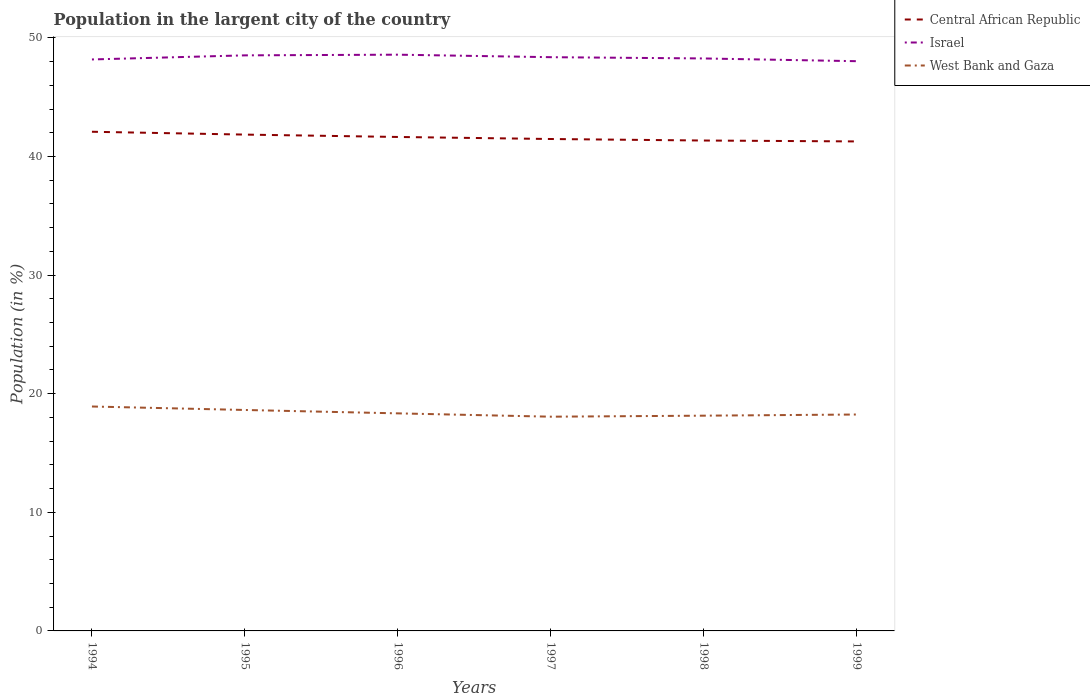Is the number of lines equal to the number of legend labels?
Ensure brevity in your answer.  Yes. Across all years, what is the maximum percentage of population in the largent city in Central African Republic?
Provide a succinct answer. 41.27. What is the total percentage of population in the largent city in West Bank and Gaza in the graph?
Offer a very short reply. 0.86. What is the difference between the highest and the second highest percentage of population in the largent city in West Bank and Gaza?
Provide a succinct answer. 0.86. Is the percentage of population in the largent city in Israel strictly greater than the percentage of population in the largent city in Central African Republic over the years?
Provide a succinct answer. No. What is the difference between two consecutive major ticks on the Y-axis?
Offer a very short reply. 10. Does the graph contain grids?
Make the answer very short. No. What is the title of the graph?
Ensure brevity in your answer.  Population in the largent city of the country. Does "Iraq" appear as one of the legend labels in the graph?
Ensure brevity in your answer.  No. What is the label or title of the X-axis?
Ensure brevity in your answer.  Years. What is the label or title of the Y-axis?
Your response must be concise. Population (in %). What is the Population (in %) of Central African Republic in 1994?
Your answer should be compact. 42.08. What is the Population (in %) in Israel in 1994?
Provide a short and direct response. 48.18. What is the Population (in %) of West Bank and Gaza in 1994?
Your answer should be very brief. 18.92. What is the Population (in %) in Central African Republic in 1995?
Give a very brief answer. 41.85. What is the Population (in %) in Israel in 1995?
Provide a short and direct response. 48.53. What is the Population (in %) in West Bank and Gaza in 1995?
Offer a terse response. 18.63. What is the Population (in %) in Central African Republic in 1996?
Make the answer very short. 41.65. What is the Population (in %) of Israel in 1996?
Your answer should be compact. 48.58. What is the Population (in %) of West Bank and Gaza in 1996?
Offer a terse response. 18.34. What is the Population (in %) of Central African Republic in 1997?
Provide a succinct answer. 41.47. What is the Population (in %) in Israel in 1997?
Your answer should be very brief. 48.37. What is the Population (in %) in West Bank and Gaza in 1997?
Give a very brief answer. 18.06. What is the Population (in %) of Central African Republic in 1998?
Offer a terse response. 41.35. What is the Population (in %) of Israel in 1998?
Your response must be concise. 48.26. What is the Population (in %) of West Bank and Gaza in 1998?
Provide a short and direct response. 18.15. What is the Population (in %) of Central African Republic in 1999?
Provide a succinct answer. 41.27. What is the Population (in %) in Israel in 1999?
Give a very brief answer. 48.03. What is the Population (in %) in West Bank and Gaza in 1999?
Ensure brevity in your answer.  18.25. Across all years, what is the maximum Population (in %) of Central African Republic?
Make the answer very short. 42.08. Across all years, what is the maximum Population (in %) of Israel?
Provide a short and direct response. 48.58. Across all years, what is the maximum Population (in %) in West Bank and Gaza?
Provide a succinct answer. 18.92. Across all years, what is the minimum Population (in %) of Central African Republic?
Your answer should be very brief. 41.27. Across all years, what is the minimum Population (in %) in Israel?
Give a very brief answer. 48.03. Across all years, what is the minimum Population (in %) of West Bank and Gaza?
Your answer should be compact. 18.06. What is the total Population (in %) of Central African Republic in the graph?
Your answer should be compact. 249.66. What is the total Population (in %) in Israel in the graph?
Provide a succinct answer. 289.96. What is the total Population (in %) in West Bank and Gaza in the graph?
Provide a succinct answer. 110.35. What is the difference between the Population (in %) of Central African Republic in 1994 and that in 1995?
Keep it short and to the point. 0.24. What is the difference between the Population (in %) of Israel in 1994 and that in 1995?
Your answer should be compact. -0.35. What is the difference between the Population (in %) in West Bank and Gaza in 1994 and that in 1995?
Your response must be concise. 0.29. What is the difference between the Population (in %) in Central African Republic in 1994 and that in 1996?
Give a very brief answer. 0.44. What is the difference between the Population (in %) in Israel in 1994 and that in 1996?
Provide a succinct answer. -0.4. What is the difference between the Population (in %) in West Bank and Gaza in 1994 and that in 1996?
Ensure brevity in your answer.  0.58. What is the difference between the Population (in %) of Central African Republic in 1994 and that in 1997?
Provide a succinct answer. 0.61. What is the difference between the Population (in %) of Israel in 1994 and that in 1997?
Give a very brief answer. -0.19. What is the difference between the Population (in %) of West Bank and Gaza in 1994 and that in 1997?
Your response must be concise. 0.86. What is the difference between the Population (in %) in Central African Republic in 1994 and that in 1998?
Your answer should be very brief. 0.74. What is the difference between the Population (in %) in Israel in 1994 and that in 1998?
Provide a succinct answer. -0.08. What is the difference between the Population (in %) of West Bank and Gaza in 1994 and that in 1998?
Make the answer very short. 0.77. What is the difference between the Population (in %) in Central African Republic in 1994 and that in 1999?
Provide a succinct answer. 0.82. What is the difference between the Population (in %) of Israel in 1994 and that in 1999?
Offer a very short reply. 0.15. What is the difference between the Population (in %) in West Bank and Gaza in 1994 and that in 1999?
Ensure brevity in your answer.  0.68. What is the difference between the Population (in %) in Central African Republic in 1995 and that in 1996?
Give a very brief answer. 0.2. What is the difference between the Population (in %) in Israel in 1995 and that in 1996?
Offer a very short reply. -0.06. What is the difference between the Population (in %) in West Bank and Gaza in 1995 and that in 1996?
Offer a very short reply. 0.29. What is the difference between the Population (in %) in Central African Republic in 1995 and that in 1997?
Offer a very short reply. 0.37. What is the difference between the Population (in %) in Israel in 1995 and that in 1997?
Provide a succinct answer. 0.15. What is the difference between the Population (in %) in West Bank and Gaza in 1995 and that in 1997?
Your answer should be very brief. 0.57. What is the difference between the Population (in %) of Israel in 1995 and that in 1998?
Ensure brevity in your answer.  0.26. What is the difference between the Population (in %) in West Bank and Gaza in 1995 and that in 1998?
Your answer should be compact. 0.48. What is the difference between the Population (in %) in Central African Republic in 1995 and that in 1999?
Your response must be concise. 0.58. What is the difference between the Population (in %) of Israel in 1995 and that in 1999?
Offer a terse response. 0.49. What is the difference between the Population (in %) in West Bank and Gaza in 1995 and that in 1999?
Offer a very short reply. 0.38. What is the difference between the Population (in %) of Central African Republic in 1996 and that in 1997?
Keep it short and to the point. 0.17. What is the difference between the Population (in %) in Israel in 1996 and that in 1997?
Provide a short and direct response. 0.21. What is the difference between the Population (in %) in West Bank and Gaza in 1996 and that in 1997?
Offer a very short reply. 0.28. What is the difference between the Population (in %) in Israel in 1996 and that in 1998?
Keep it short and to the point. 0.32. What is the difference between the Population (in %) in West Bank and Gaza in 1996 and that in 1998?
Your answer should be compact. 0.19. What is the difference between the Population (in %) in Central African Republic in 1996 and that in 1999?
Provide a short and direct response. 0.38. What is the difference between the Population (in %) in Israel in 1996 and that in 1999?
Your response must be concise. 0.55. What is the difference between the Population (in %) of West Bank and Gaza in 1996 and that in 1999?
Offer a very short reply. 0.1. What is the difference between the Population (in %) of Central African Republic in 1997 and that in 1998?
Make the answer very short. 0.13. What is the difference between the Population (in %) in Israel in 1997 and that in 1998?
Your response must be concise. 0.11. What is the difference between the Population (in %) of West Bank and Gaza in 1997 and that in 1998?
Provide a succinct answer. -0.09. What is the difference between the Population (in %) in Central African Republic in 1997 and that in 1999?
Your answer should be very brief. 0.2. What is the difference between the Population (in %) of Israel in 1997 and that in 1999?
Offer a very short reply. 0.34. What is the difference between the Population (in %) in West Bank and Gaza in 1997 and that in 1999?
Make the answer very short. -0.18. What is the difference between the Population (in %) of Central African Republic in 1998 and that in 1999?
Provide a succinct answer. 0.08. What is the difference between the Population (in %) of Israel in 1998 and that in 1999?
Offer a terse response. 0.23. What is the difference between the Population (in %) in West Bank and Gaza in 1998 and that in 1999?
Your answer should be very brief. -0.1. What is the difference between the Population (in %) of Central African Republic in 1994 and the Population (in %) of Israel in 1995?
Provide a short and direct response. -6.44. What is the difference between the Population (in %) of Central African Republic in 1994 and the Population (in %) of West Bank and Gaza in 1995?
Keep it short and to the point. 23.46. What is the difference between the Population (in %) in Israel in 1994 and the Population (in %) in West Bank and Gaza in 1995?
Your response must be concise. 29.55. What is the difference between the Population (in %) in Central African Republic in 1994 and the Population (in %) in Israel in 1996?
Make the answer very short. -6.5. What is the difference between the Population (in %) of Central African Republic in 1994 and the Population (in %) of West Bank and Gaza in 1996?
Your answer should be compact. 23.74. What is the difference between the Population (in %) of Israel in 1994 and the Population (in %) of West Bank and Gaza in 1996?
Provide a short and direct response. 29.84. What is the difference between the Population (in %) of Central African Republic in 1994 and the Population (in %) of Israel in 1997?
Provide a succinct answer. -6.29. What is the difference between the Population (in %) in Central African Republic in 1994 and the Population (in %) in West Bank and Gaza in 1997?
Ensure brevity in your answer.  24.02. What is the difference between the Population (in %) of Israel in 1994 and the Population (in %) of West Bank and Gaza in 1997?
Offer a very short reply. 30.12. What is the difference between the Population (in %) of Central African Republic in 1994 and the Population (in %) of Israel in 1998?
Your answer should be very brief. -6.18. What is the difference between the Population (in %) of Central African Republic in 1994 and the Population (in %) of West Bank and Gaza in 1998?
Provide a short and direct response. 23.94. What is the difference between the Population (in %) of Israel in 1994 and the Population (in %) of West Bank and Gaza in 1998?
Ensure brevity in your answer.  30.03. What is the difference between the Population (in %) of Central African Republic in 1994 and the Population (in %) of Israel in 1999?
Ensure brevity in your answer.  -5.95. What is the difference between the Population (in %) of Central African Republic in 1994 and the Population (in %) of West Bank and Gaza in 1999?
Your answer should be compact. 23.84. What is the difference between the Population (in %) of Israel in 1994 and the Population (in %) of West Bank and Gaza in 1999?
Make the answer very short. 29.93. What is the difference between the Population (in %) in Central African Republic in 1995 and the Population (in %) in Israel in 1996?
Provide a succinct answer. -6.74. What is the difference between the Population (in %) in Central African Republic in 1995 and the Population (in %) in West Bank and Gaza in 1996?
Your response must be concise. 23.5. What is the difference between the Population (in %) of Israel in 1995 and the Population (in %) of West Bank and Gaza in 1996?
Your response must be concise. 30.18. What is the difference between the Population (in %) in Central African Republic in 1995 and the Population (in %) in Israel in 1997?
Your answer should be compact. -6.53. What is the difference between the Population (in %) in Central African Republic in 1995 and the Population (in %) in West Bank and Gaza in 1997?
Make the answer very short. 23.78. What is the difference between the Population (in %) of Israel in 1995 and the Population (in %) of West Bank and Gaza in 1997?
Ensure brevity in your answer.  30.46. What is the difference between the Population (in %) in Central African Republic in 1995 and the Population (in %) in Israel in 1998?
Provide a succinct answer. -6.42. What is the difference between the Population (in %) of Central African Republic in 1995 and the Population (in %) of West Bank and Gaza in 1998?
Make the answer very short. 23.7. What is the difference between the Population (in %) in Israel in 1995 and the Population (in %) in West Bank and Gaza in 1998?
Provide a short and direct response. 30.38. What is the difference between the Population (in %) of Central African Republic in 1995 and the Population (in %) of Israel in 1999?
Make the answer very short. -6.19. What is the difference between the Population (in %) of Central African Republic in 1995 and the Population (in %) of West Bank and Gaza in 1999?
Offer a terse response. 23.6. What is the difference between the Population (in %) in Israel in 1995 and the Population (in %) in West Bank and Gaza in 1999?
Make the answer very short. 30.28. What is the difference between the Population (in %) in Central African Republic in 1996 and the Population (in %) in Israel in 1997?
Keep it short and to the point. -6.73. What is the difference between the Population (in %) of Central African Republic in 1996 and the Population (in %) of West Bank and Gaza in 1997?
Make the answer very short. 23.58. What is the difference between the Population (in %) in Israel in 1996 and the Population (in %) in West Bank and Gaza in 1997?
Offer a terse response. 30.52. What is the difference between the Population (in %) of Central African Republic in 1996 and the Population (in %) of Israel in 1998?
Offer a very short reply. -6.62. What is the difference between the Population (in %) in Central African Republic in 1996 and the Population (in %) in West Bank and Gaza in 1998?
Make the answer very short. 23.5. What is the difference between the Population (in %) in Israel in 1996 and the Population (in %) in West Bank and Gaza in 1998?
Keep it short and to the point. 30.44. What is the difference between the Population (in %) in Central African Republic in 1996 and the Population (in %) in Israel in 1999?
Your answer should be very brief. -6.39. What is the difference between the Population (in %) of Central African Republic in 1996 and the Population (in %) of West Bank and Gaza in 1999?
Provide a succinct answer. 23.4. What is the difference between the Population (in %) in Israel in 1996 and the Population (in %) in West Bank and Gaza in 1999?
Offer a very short reply. 30.34. What is the difference between the Population (in %) of Central African Republic in 1997 and the Population (in %) of Israel in 1998?
Your answer should be compact. -6.79. What is the difference between the Population (in %) in Central African Republic in 1997 and the Population (in %) in West Bank and Gaza in 1998?
Your response must be concise. 23.33. What is the difference between the Population (in %) in Israel in 1997 and the Population (in %) in West Bank and Gaza in 1998?
Your response must be concise. 30.22. What is the difference between the Population (in %) in Central African Republic in 1997 and the Population (in %) in Israel in 1999?
Your response must be concise. -6.56. What is the difference between the Population (in %) in Central African Republic in 1997 and the Population (in %) in West Bank and Gaza in 1999?
Ensure brevity in your answer.  23.23. What is the difference between the Population (in %) of Israel in 1997 and the Population (in %) of West Bank and Gaza in 1999?
Provide a short and direct response. 30.13. What is the difference between the Population (in %) of Central African Republic in 1998 and the Population (in %) of Israel in 1999?
Make the answer very short. -6.69. What is the difference between the Population (in %) of Central African Republic in 1998 and the Population (in %) of West Bank and Gaza in 1999?
Your answer should be very brief. 23.1. What is the difference between the Population (in %) of Israel in 1998 and the Population (in %) of West Bank and Gaza in 1999?
Ensure brevity in your answer.  30.02. What is the average Population (in %) of Central African Republic per year?
Offer a terse response. 41.61. What is the average Population (in %) in Israel per year?
Make the answer very short. 48.33. What is the average Population (in %) of West Bank and Gaza per year?
Your answer should be very brief. 18.39. In the year 1994, what is the difference between the Population (in %) of Central African Republic and Population (in %) of Israel?
Make the answer very short. -6.1. In the year 1994, what is the difference between the Population (in %) of Central African Republic and Population (in %) of West Bank and Gaza?
Keep it short and to the point. 23.16. In the year 1994, what is the difference between the Population (in %) of Israel and Population (in %) of West Bank and Gaza?
Ensure brevity in your answer.  29.26. In the year 1995, what is the difference between the Population (in %) in Central African Republic and Population (in %) in Israel?
Offer a terse response. -6.68. In the year 1995, what is the difference between the Population (in %) in Central African Republic and Population (in %) in West Bank and Gaza?
Your answer should be compact. 23.22. In the year 1995, what is the difference between the Population (in %) of Israel and Population (in %) of West Bank and Gaza?
Your answer should be compact. 29.9. In the year 1996, what is the difference between the Population (in %) in Central African Republic and Population (in %) in Israel?
Make the answer very short. -6.94. In the year 1996, what is the difference between the Population (in %) in Central African Republic and Population (in %) in West Bank and Gaza?
Ensure brevity in your answer.  23.3. In the year 1996, what is the difference between the Population (in %) in Israel and Population (in %) in West Bank and Gaza?
Offer a terse response. 30.24. In the year 1997, what is the difference between the Population (in %) in Central African Republic and Population (in %) in Israel?
Provide a succinct answer. -6.9. In the year 1997, what is the difference between the Population (in %) in Central African Republic and Population (in %) in West Bank and Gaza?
Offer a terse response. 23.41. In the year 1997, what is the difference between the Population (in %) of Israel and Population (in %) of West Bank and Gaza?
Ensure brevity in your answer.  30.31. In the year 1998, what is the difference between the Population (in %) of Central African Republic and Population (in %) of Israel?
Your answer should be compact. -6.92. In the year 1998, what is the difference between the Population (in %) in Central African Republic and Population (in %) in West Bank and Gaza?
Offer a terse response. 23.2. In the year 1998, what is the difference between the Population (in %) in Israel and Population (in %) in West Bank and Gaza?
Provide a succinct answer. 30.12. In the year 1999, what is the difference between the Population (in %) in Central African Republic and Population (in %) in Israel?
Your response must be concise. -6.76. In the year 1999, what is the difference between the Population (in %) in Central African Republic and Population (in %) in West Bank and Gaza?
Make the answer very short. 23.02. In the year 1999, what is the difference between the Population (in %) of Israel and Population (in %) of West Bank and Gaza?
Your answer should be compact. 29.79. What is the ratio of the Population (in %) of Central African Republic in 1994 to that in 1995?
Provide a short and direct response. 1.01. What is the ratio of the Population (in %) of Israel in 1994 to that in 1995?
Your answer should be very brief. 0.99. What is the ratio of the Population (in %) in West Bank and Gaza in 1994 to that in 1995?
Ensure brevity in your answer.  1.02. What is the ratio of the Population (in %) of Central African Republic in 1994 to that in 1996?
Give a very brief answer. 1.01. What is the ratio of the Population (in %) of West Bank and Gaza in 1994 to that in 1996?
Your answer should be very brief. 1.03. What is the ratio of the Population (in %) of Central African Republic in 1994 to that in 1997?
Provide a short and direct response. 1.01. What is the ratio of the Population (in %) in Israel in 1994 to that in 1997?
Offer a very short reply. 1. What is the ratio of the Population (in %) in West Bank and Gaza in 1994 to that in 1997?
Ensure brevity in your answer.  1.05. What is the ratio of the Population (in %) of Central African Republic in 1994 to that in 1998?
Keep it short and to the point. 1.02. What is the ratio of the Population (in %) of Israel in 1994 to that in 1998?
Your response must be concise. 1. What is the ratio of the Population (in %) of West Bank and Gaza in 1994 to that in 1998?
Provide a short and direct response. 1.04. What is the ratio of the Population (in %) in Central African Republic in 1994 to that in 1999?
Make the answer very short. 1.02. What is the ratio of the Population (in %) of Israel in 1994 to that in 1999?
Your answer should be very brief. 1. What is the ratio of the Population (in %) in West Bank and Gaza in 1994 to that in 1999?
Provide a short and direct response. 1.04. What is the ratio of the Population (in %) in Central African Republic in 1995 to that in 1996?
Give a very brief answer. 1. What is the ratio of the Population (in %) of Israel in 1995 to that in 1996?
Offer a very short reply. 1. What is the ratio of the Population (in %) of West Bank and Gaza in 1995 to that in 1996?
Offer a terse response. 1.02. What is the ratio of the Population (in %) of West Bank and Gaza in 1995 to that in 1997?
Your answer should be very brief. 1.03. What is the ratio of the Population (in %) of Central African Republic in 1995 to that in 1998?
Your answer should be compact. 1.01. What is the ratio of the Population (in %) in Israel in 1995 to that in 1998?
Make the answer very short. 1.01. What is the ratio of the Population (in %) of West Bank and Gaza in 1995 to that in 1998?
Offer a very short reply. 1.03. What is the ratio of the Population (in %) of Israel in 1995 to that in 1999?
Provide a short and direct response. 1.01. What is the ratio of the Population (in %) in Central African Republic in 1996 to that in 1997?
Provide a short and direct response. 1. What is the ratio of the Population (in %) of Israel in 1996 to that in 1997?
Offer a very short reply. 1. What is the ratio of the Population (in %) in West Bank and Gaza in 1996 to that in 1997?
Give a very brief answer. 1.02. What is the ratio of the Population (in %) in Central African Republic in 1996 to that in 1998?
Offer a terse response. 1.01. What is the ratio of the Population (in %) of Israel in 1996 to that in 1998?
Your response must be concise. 1.01. What is the ratio of the Population (in %) in West Bank and Gaza in 1996 to that in 1998?
Give a very brief answer. 1.01. What is the ratio of the Population (in %) of Central African Republic in 1996 to that in 1999?
Your answer should be very brief. 1.01. What is the ratio of the Population (in %) in Israel in 1996 to that in 1999?
Offer a terse response. 1.01. What is the ratio of the Population (in %) of West Bank and Gaza in 1996 to that in 1999?
Give a very brief answer. 1.01. What is the ratio of the Population (in %) in Central African Republic in 1997 to that in 1998?
Your answer should be compact. 1. What is the ratio of the Population (in %) of West Bank and Gaza in 1997 to that in 1998?
Provide a short and direct response. 1. What is the ratio of the Population (in %) in Central African Republic in 1997 to that in 1999?
Your answer should be compact. 1. What is the ratio of the Population (in %) in Israel in 1997 to that in 1999?
Make the answer very short. 1.01. What is the ratio of the Population (in %) in West Bank and Gaza in 1997 to that in 1999?
Your answer should be compact. 0.99. What is the difference between the highest and the second highest Population (in %) in Central African Republic?
Offer a terse response. 0.24. What is the difference between the highest and the second highest Population (in %) of Israel?
Your answer should be very brief. 0.06. What is the difference between the highest and the second highest Population (in %) of West Bank and Gaza?
Provide a short and direct response. 0.29. What is the difference between the highest and the lowest Population (in %) in Central African Republic?
Your response must be concise. 0.82. What is the difference between the highest and the lowest Population (in %) in Israel?
Your answer should be very brief. 0.55. What is the difference between the highest and the lowest Population (in %) in West Bank and Gaza?
Offer a very short reply. 0.86. 